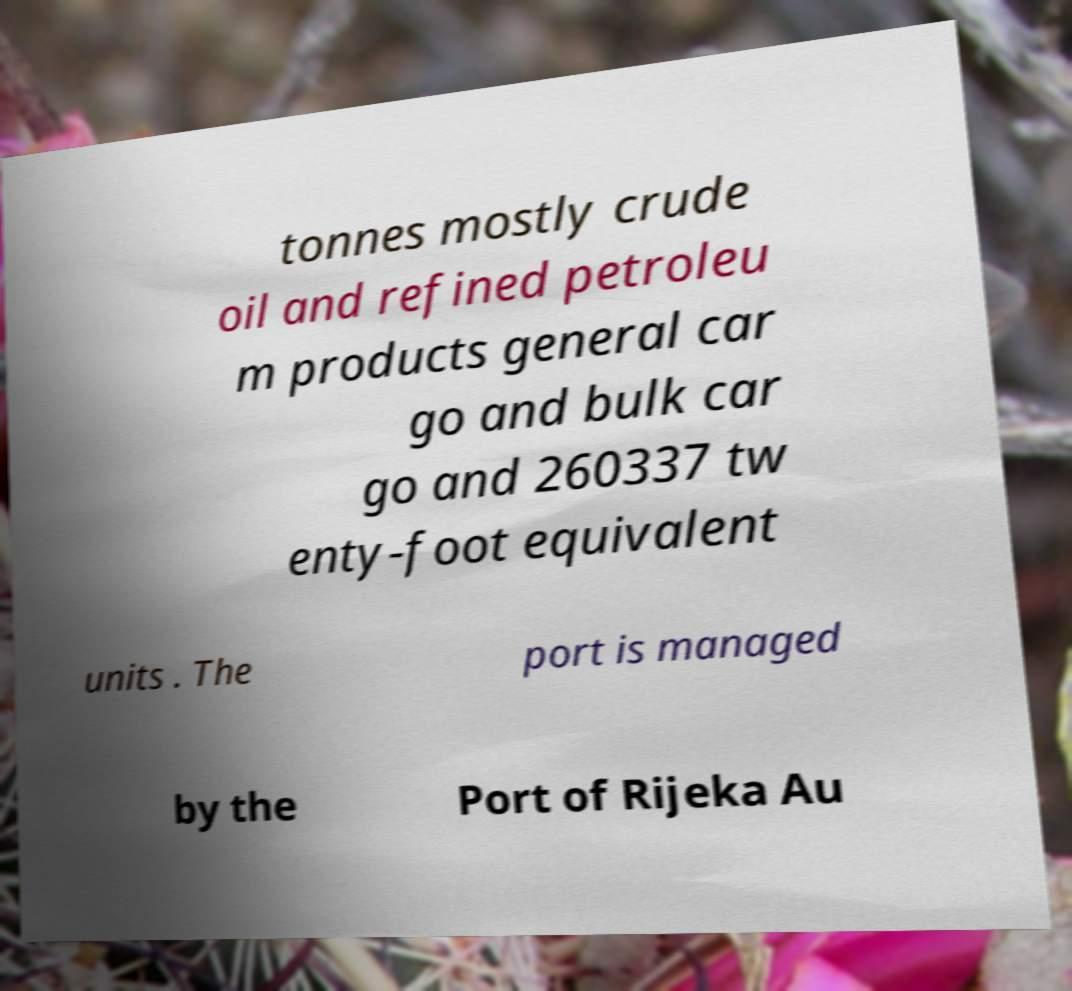Could you assist in decoding the text presented in this image and type it out clearly? tonnes mostly crude oil and refined petroleu m products general car go and bulk car go and 260337 tw enty-foot equivalent units . The port is managed by the Port of Rijeka Au 